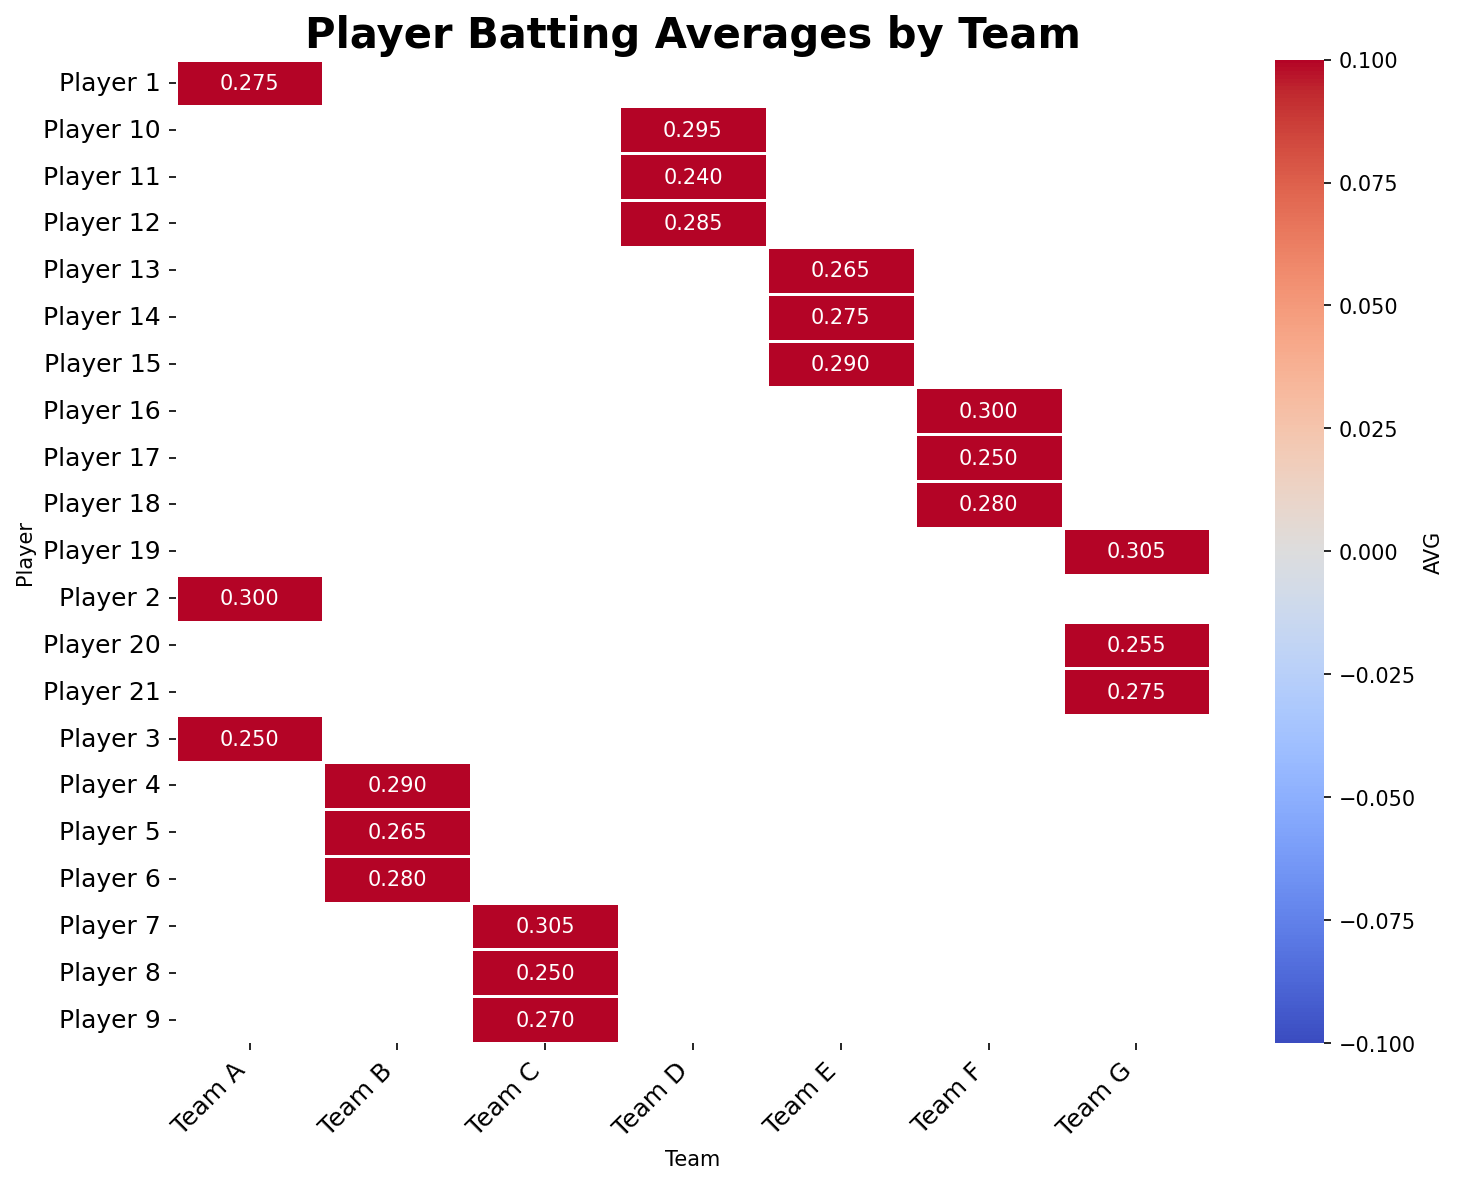Which player has the highest batting average in Team C? By looking at the heatmap, find the row associated with Team C and visually scan for the highest value in the AVG column within that team. Player 7 has the highest value, which is 0.305.
Answer: Player 7 Which team has the player with the lowest batting average in the entire league? By scanning the heatmap, the player with the lowest batting average in the entire league is Player 11 from Team D with an average of 0.240.
Answer: Team D Compare the batting averages of Player 2 from Team A and Player 16 from Team F. Which one is higher? Find the locations of Player 2 from Team A and Player 16 from Team F in the heatmap. Player 2 has an average of 0.300, and Player 16 has an average of 0.300. Both are equal.
Answer: Equal What's the average batting average of all the players in Team B? To compute the average, sum the batting averages of all players in Team B and divide by the number of players: (0.290 + 0.265 + 0.280) / 3 = 0.278.
Answer: 0.278 Which player from Team G has a better batting average than Player 10 from Team D? Player 10 from Team D has a batting average of 0.295. Looking at Team G, both Player 19 with 0.305 and Player 21 with 0.275 outperform Player 10's average.
Answer: Player 19 What is the difference in batting averages between Player 5 from Team B and Player 14 from Team E? Calculate the difference between Player 5's and Player 14's batting averages: 0.265 - 0.275 = -0.01.
Answer: -0.01 Which players have batting averages higher than 0.300? By scanning the heatmap for values higher than 0.300, we identify Player 2 (0.300) from Team A, Player 7 (0.305) from Team C, Player 16 (0.300) from Team F, and Player 19 (0.305) from Team G.
Answer: Player 2, Player 7, Player 16, Player 19 What is the combined batting average for all players in Team F? Sum the batting averages of all players in Team F: 0.300 + 0.250 + 0.280 = 0.830.
Answer: 0.830 